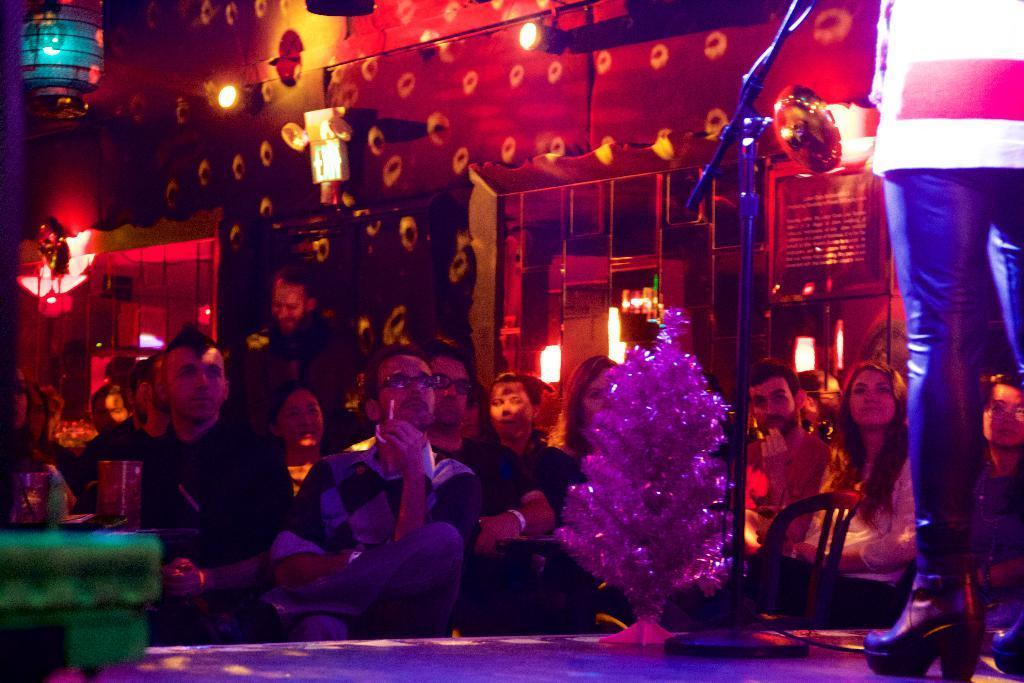Describe this image in one or two sentences. In this image there are a few people seated on chairs and watching a performance by a person on the stage. 